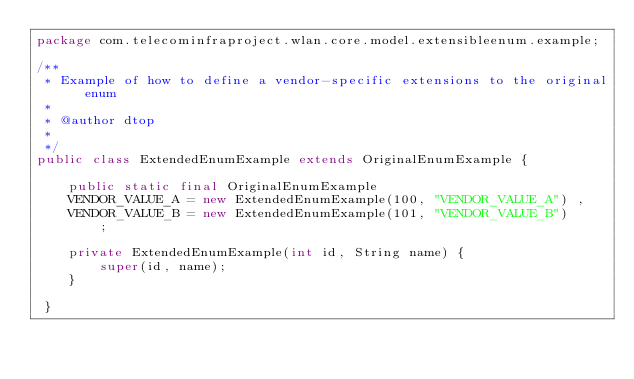Convert code to text. <code><loc_0><loc_0><loc_500><loc_500><_Java_>package com.telecominfraproject.wlan.core.model.extensibleenum.example;

/**
 * Example of how to define a vendor-specific extensions to the original enum
 *
 * @author dtop
 *
 */
public class ExtendedEnumExample extends OriginalEnumExample {
        
    public static final OriginalEnumExample 
    VENDOR_VALUE_A = new ExtendedEnumExample(100, "VENDOR_VALUE_A") ,
    VENDOR_VALUE_B = new ExtendedEnumExample(101, "VENDOR_VALUE_B")
        ;
    
    private ExtendedEnumExample(int id, String name) {
        super(id, name);
    }

 }
</code> 